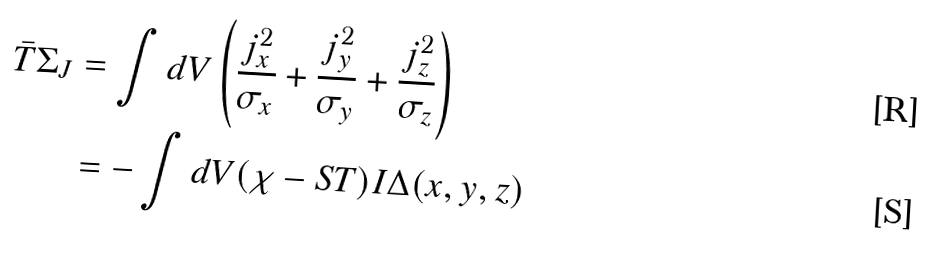Convert formula to latex. <formula><loc_0><loc_0><loc_500><loc_500>\bar { T } \Sigma _ { J } & = \int d V \left ( \frac { j _ { x } ^ { 2 } } { \sigma _ { x } } + \frac { j _ { y } ^ { 2 } } { \sigma _ { y } } + \frac { j _ { z } ^ { 2 } } { \sigma _ { z } } \right ) \\ & = - \int d V ( \chi - S T ) I \Delta ( x , y , z )</formula> 